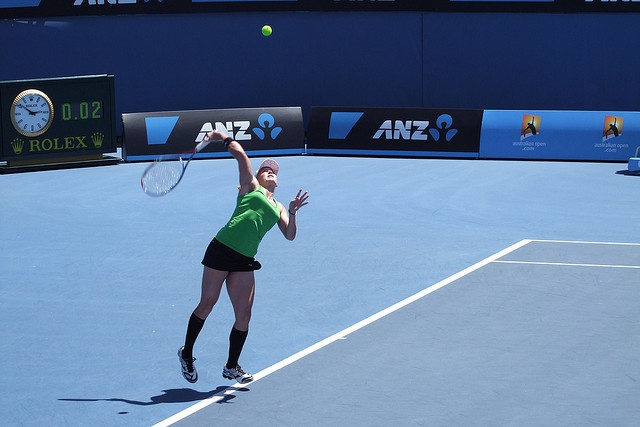Describe the objects in this image and their specific colors. I can see people in darkblue, black, purple, and darkgreen tones, tennis racket in darkblue, lightblue, and gray tones, clock in darkblue, gray, and blue tones, clock in darkblue, black, darkgreen, and navy tones, and sports ball in darkblue, green, khaki, and lightgreen tones in this image. 